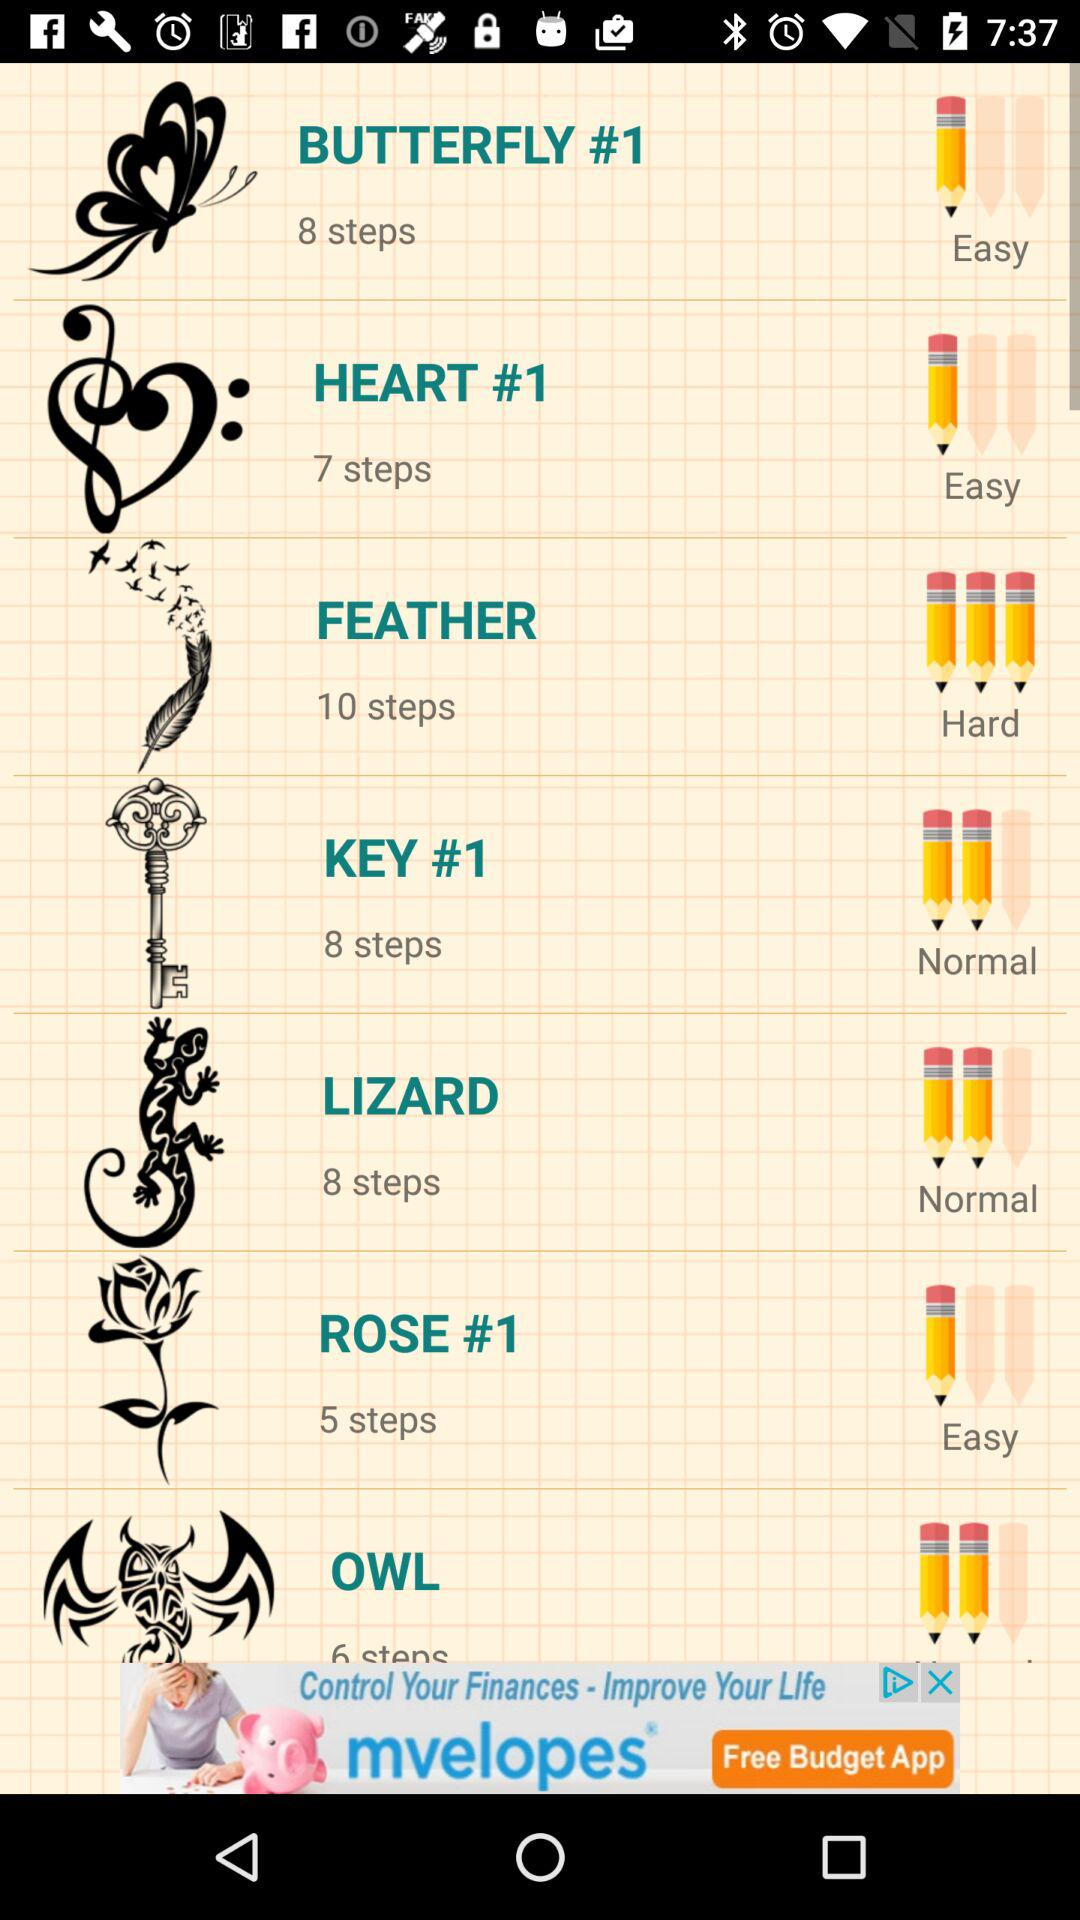What is the level of the "BUTTERFLY"? The level is "Easy". 